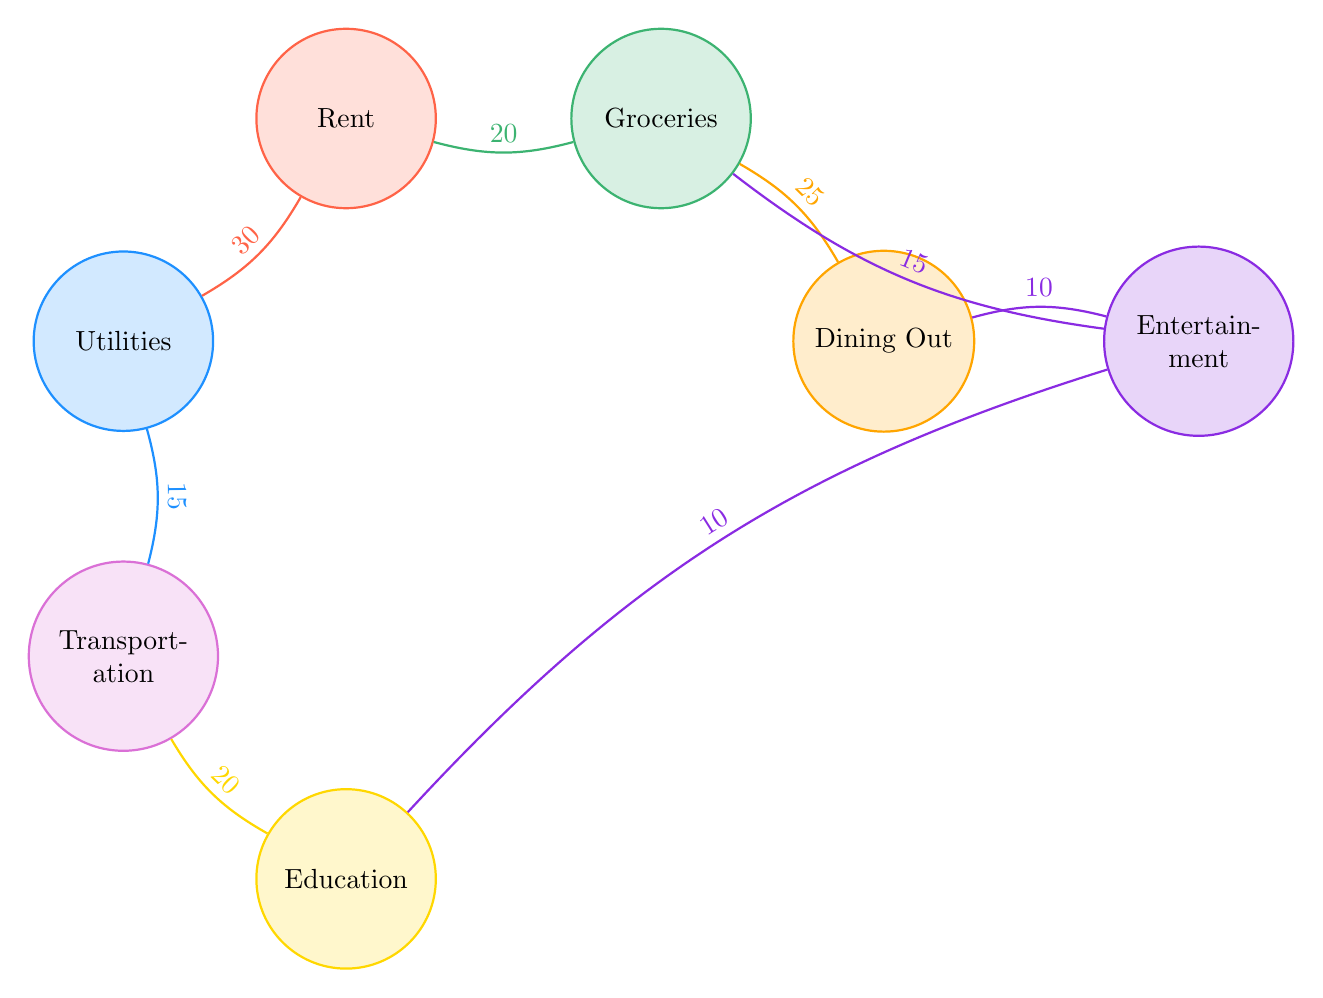what is the value of the link between Rent and Utilities? The diagram shows a link from Rent to Utilities with a value labeled above it indicating the amount spent. The value is directly visible in the diagram.
Answer: 30 what is the total number of nodes in the diagram? The diagram presents a total of 7 distinct categories (nodes), which can be counted from the list provided.
Answer: 7 which category has a higher expenditure: Dining Out or Entertainment? The diagram allows for a visual comparison of the two categories by examining the values connected to Dining Out (10) and Entertainment (15). Since 15 is greater than 10, Entertainment has a higher expenditure.
Answer: Entertainment what is the total expenditure for Groceries? The diagram indicates the flows originating from the Groceries node. There are two outputs: one to Dining Out with a value of 25 and another to Entertainment with a value of 15. Adding these values gives the total expenditure for Groceries: 25 + 15 = 40.
Answer: 40 which two categories are linked with the same value? Upon analyzing the diagram, it shows that the links from Groceries to Dining Out (25) and from Utilities to Transportation (15) are unique, while the link from Dining Out to Entertainment has a distinct value of 10. Only the link from Education to Entertainment shares a value of 10 with another category, making them identical.
Answer: Education and Entertainment what is the value of the link from Transportation to Education? The diagram's link between Transportation and Education clearly indicates the monetary value positioned above the line connecting them. This value can be directly read from the diagram.
Answer: 20 how many total links are there in the diagram? The diagram can be analyzed by counting the pairs of source and target connections shown. There are 8 links between the various categories displayed in the diagram.
Answer: 8 what is the flow of expenditure from Utilities? Starting from the Utilities node, the only outgoing link is directed towards Transportation. This connection is labeled with a specific value, which indicates how much is spent from Utilities to Transportation. The diagram confirms this information clearly.
Answer: 15 which node contributes to the Education node? By observing the outgoing links from nodes, the diagram reveals that Education is reached from two sources: Transportation (20) and Entertainment (10). Thus, both categories contribute expenditures to Education.
Answer: Transportation and Entertainment 